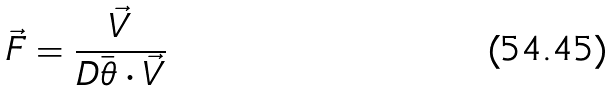Convert formula to latex. <formula><loc_0><loc_0><loc_500><loc_500>\vec { F } = \frac { \vec { V } } { D \bar { \theta } \cdot \vec { V } }</formula> 